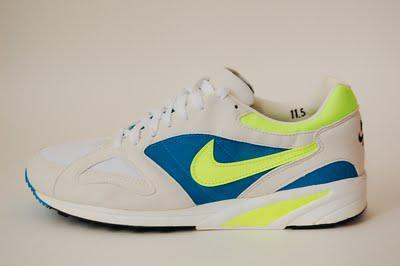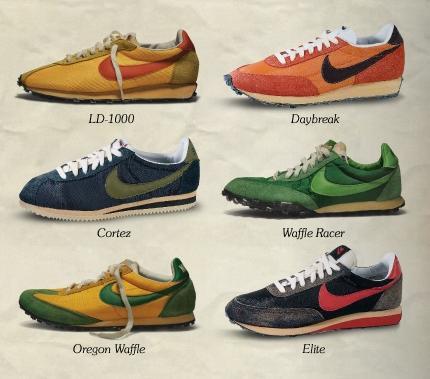The first image is the image on the left, the second image is the image on the right. For the images displayed, is the sentence "The left image contains no more than one shoe." factually correct? Answer yes or no. Yes. The first image is the image on the left, the second image is the image on the right. Given the left and right images, does the statement "Every shoe is posed facing directly leftward, and one image contains a single shoe." hold true? Answer yes or no. Yes. 